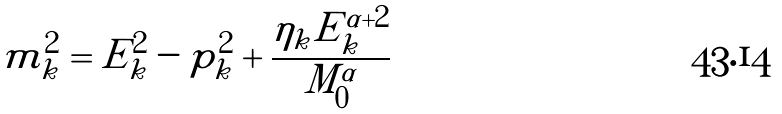Convert formula to latex. <formula><loc_0><loc_0><loc_500><loc_500>m _ { k } ^ { 2 } = E ^ { 2 } _ { k } - p _ { k } ^ { 2 } + \frac { \eta _ { k } E _ { k } ^ { \alpha + 2 } } { M _ { 0 } ^ { \alpha } }</formula> 